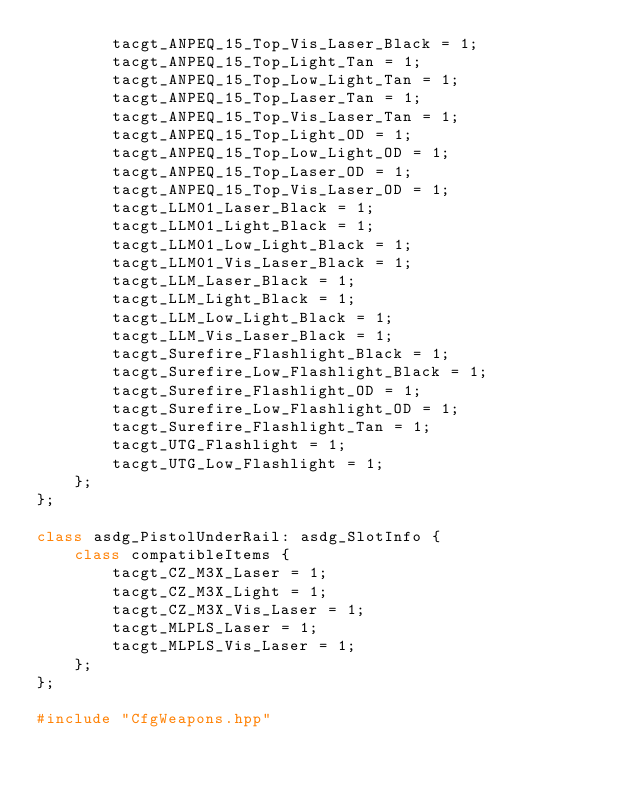Convert code to text. <code><loc_0><loc_0><loc_500><loc_500><_C++_>        tacgt_ANPEQ_15_Top_Vis_Laser_Black = 1;
        tacgt_ANPEQ_15_Top_Light_Tan = 1;
        tacgt_ANPEQ_15_Top_Low_Light_Tan = 1;
        tacgt_ANPEQ_15_Top_Laser_Tan = 1;
        tacgt_ANPEQ_15_Top_Vis_Laser_Tan = 1;
        tacgt_ANPEQ_15_Top_Light_OD = 1;
        tacgt_ANPEQ_15_Top_Low_Light_OD = 1;
        tacgt_ANPEQ_15_Top_Laser_OD = 1;
        tacgt_ANPEQ_15_Top_Vis_Laser_OD = 1;
        tacgt_LLM01_Laser_Black = 1;
        tacgt_LLM01_Light_Black = 1;
        tacgt_LLM01_Low_Light_Black = 1;
        tacgt_LLM01_Vis_Laser_Black = 1;
        tacgt_LLM_Laser_Black = 1;
        tacgt_LLM_Light_Black = 1;
        tacgt_LLM_Low_Light_Black = 1;
        tacgt_LLM_Vis_Laser_Black = 1;
        tacgt_Surefire_Flashlight_Black = 1;
        tacgt_Surefire_Low_Flashlight_Black = 1;
        tacgt_Surefire_Flashlight_OD = 1;
        tacgt_Surefire_Low_Flashlight_OD = 1;
        tacgt_Surefire_Flashlight_Tan = 1;
        tacgt_UTG_Flashlight = 1;
        tacgt_UTG_Low_Flashlight = 1;
    };
};

class asdg_PistolUnderRail: asdg_SlotInfo {
    class compatibleItems {
        tacgt_CZ_M3X_Laser = 1;
        tacgt_CZ_M3X_Light = 1;
        tacgt_CZ_M3X_Vis_Laser = 1;
        tacgt_MLPLS_Laser = 1;
        tacgt_MLPLS_Vis_Laser = 1;
    };
};

#include "CfgWeapons.hpp"
</code> 